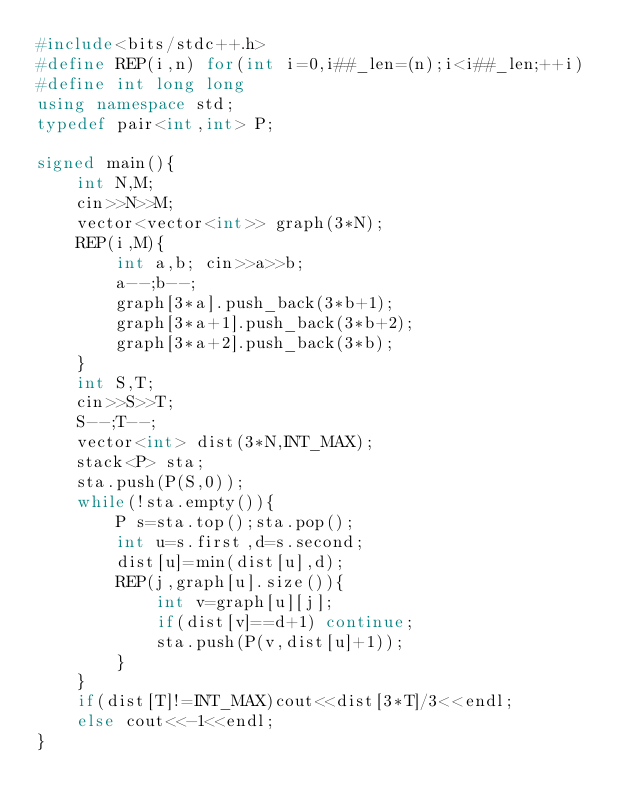<code> <loc_0><loc_0><loc_500><loc_500><_C++_>#include<bits/stdc++.h>
#define REP(i,n) for(int i=0,i##_len=(n);i<i##_len;++i)
#define int long long
using namespace std;
typedef pair<int,int> P;

signed main(){
    int N,M;
    cin>>N>>M;
    vector<vector<int>> graph(3*N);
    REP(i,M){
        int a,b; cin>>a>>b;
        a--;b--;
        graph[3*a].push_back(3*b+1);
        graph[3*a+1].push_back(3*b+2);
        graph[3*a+2].push_back(3*b);
    }
    int S,T;
    cin>>S>>T;
    S--;T--;
    vector<int> dist(3*N,INT_MAX);
    stack<P> sta;
    sta.push(P(S,0));
    while(!sta.empty()){
        P s=sta.top();sta.pop();
        int u=s.first,d=s.second;
        dist[u]=min(dist[u],d);
        REP(j,graph[u].size()){
            int v=graph[u][j];
            if(dist[v]==d+1) continue;
            sta.push(P(v,dist[u]+1));
        }
    }
    if(dist[T]!=INT_MAX)cout<<dist[3*T]/3<<endl;
    else cout<<-1<<endl;
}</code> 